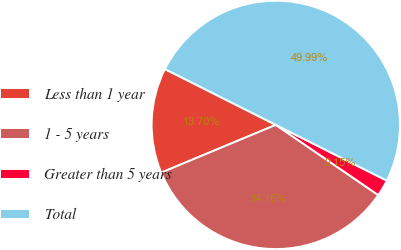<chart> <loc_0><loc_0><loc_500><loc_500><pie_chart><fcel>Less than 1 year<fcel>1 - 5 years<fcel>Greater than 5 years<fcel>Total<nl><fcel>13.7%<fcel>34.16%<fcel>2.15%<fcel>50.0%<nl></chart> 